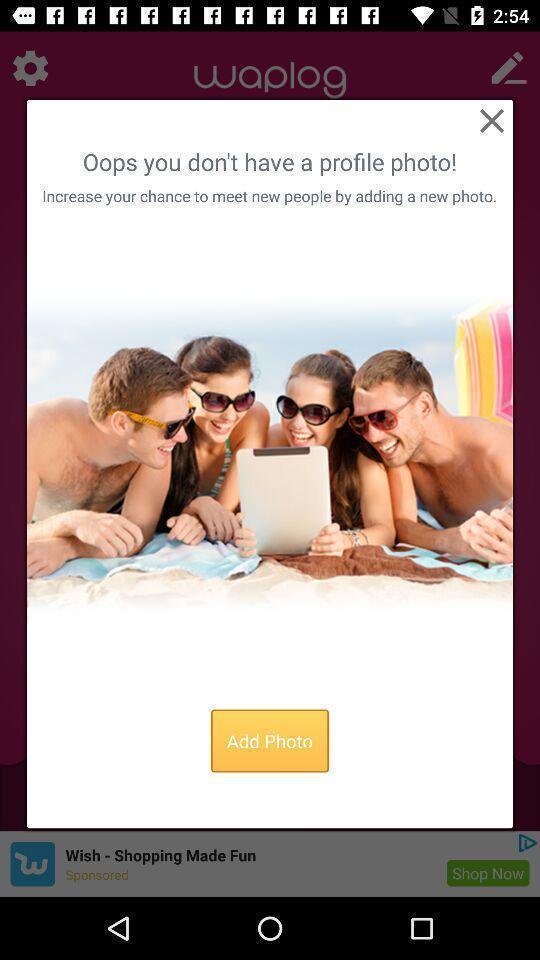Provide a textual representation of this image. Popup to add photo in the social network app. 